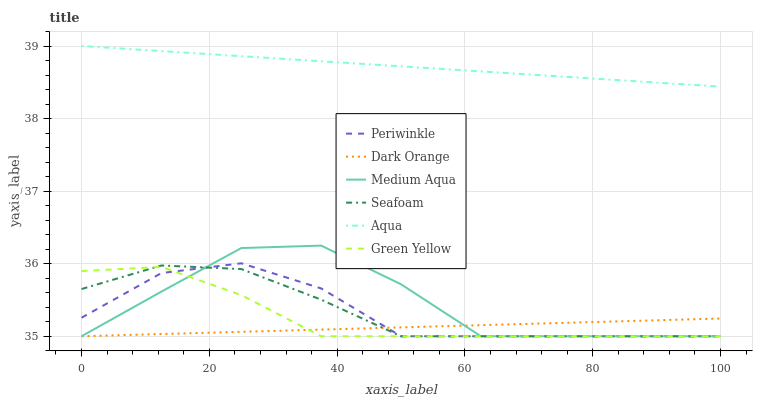Does Dark Orange have the minimum area under the curve?
Answer yes or no. Yes. Does Aqua have the maximum area under the curve?
Answer yes or no. Yes. Does Seafoam have the minimum area under the curve?
Answer yes or no. No. Does Seafoam have the maximum area under the curve?
Answer yes or no. No. Is Aqua the smoothest?
Answer yes or no. Yes. Is Medium Aqua the roughest?
Answer yes or no. Yes. Is Seafoam the smoothest?
Answer yes or no. No. Is Seafoam the roughest?
Answer yes or no. No. Does Dark Orange have the lowest value?
Answer yes or no. Yes. Does Aqua have the lowest value?
Answer yes or no. No. Does Aqua have the highest value?
Answer yes or no. Yes. Does Seafoam have the highest value?
Answer yes or no. No. Is Dark Orange less than Aqua?
Answer yes or no. Yes. Is Aqua greater than Seafoam?
Answer yes or no. Yes. Does Green Yellow intersect Medium Aqua?
Answer yes or no. Yes. Is Green Yellow less than Medium Aqua?
Answer yes or no. No. Is Green Yellow greater than Medium Aqua?
Answer yes or no. No. Does Dark Orange intersect Aqua?
Answer yes or no. No. 